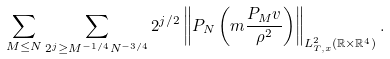<formula> <loc_0><loc_0><loc_500><loc_500>\sum _ { M \leq N } \sum _ { 2 ^ { j } \geq M ^ { - 1 / 4 } N ^ { - 3 / 4 } } 2 ^ { j / 2 } \left \| P _ { N } \left ( m \frac { P _ { M } v } { \rho ^ { 2 } } \right ) \right \| _ { L _ { T , x } ^ { 2 } ( \mathbb { R } \times \mathbb { R } ^ { 4 } ) } .</formula> 